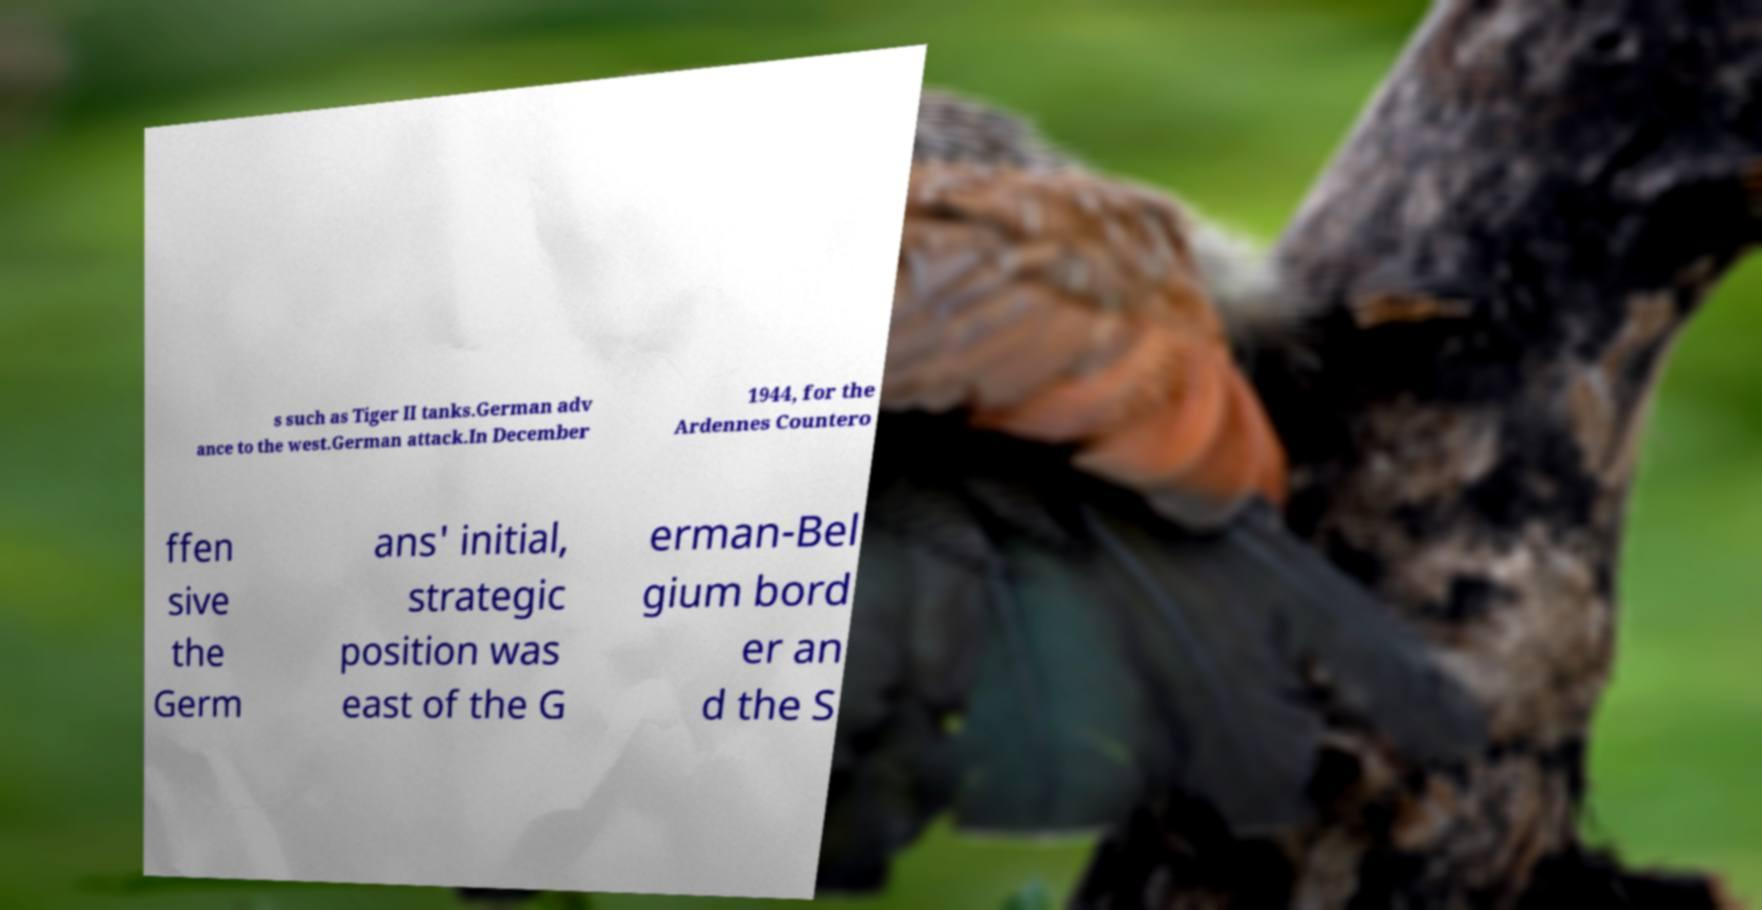Could you assist in decoding the text presented in this image and type it out clearly? s such as Tiger II tanks.German adv ance to the west.German attack.In December 1944, for the Ardennes Countero ffen sive the Germ ans' initial, strategic position was east of the G erman-Bel gium bord er an d the S 